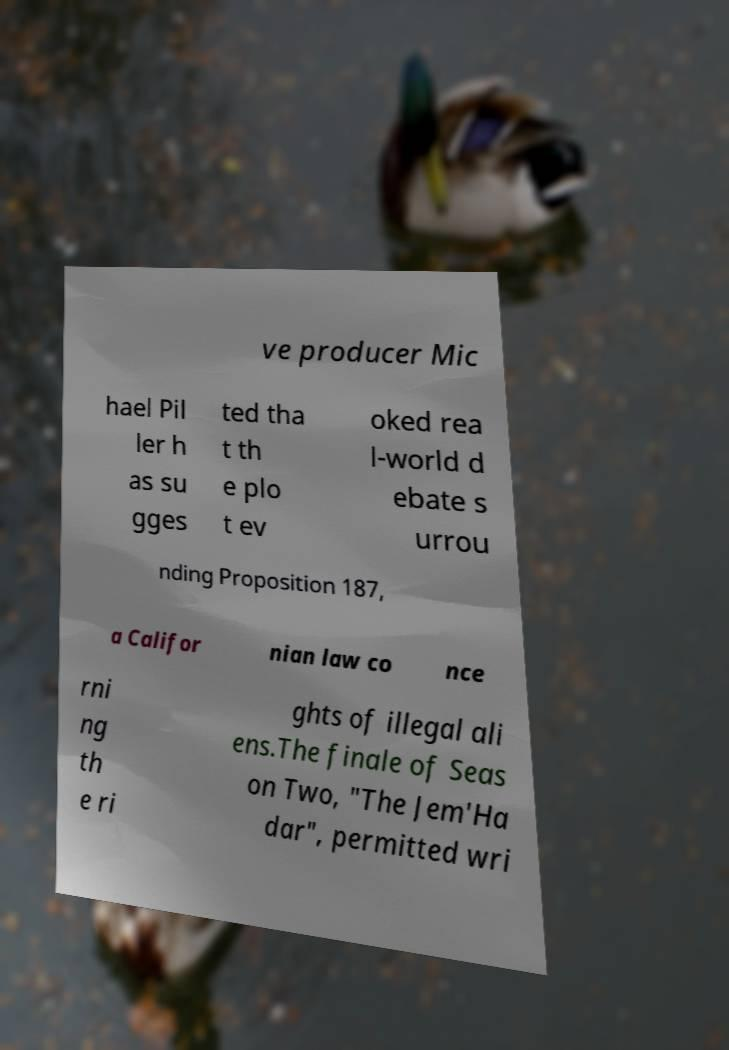Please read and relay the text visible in this image. What does it say? ve producer Mic hael Pil ler h as su gges ted tha t th e plo t ev oked rea l-world d ebate s urrou nding Proposition 187, a Califor nian law co nce rni ng th e ri ghts of illegal ali ens.The finale of Seas on Two, "The Jem'Ha dar", permitted wri 